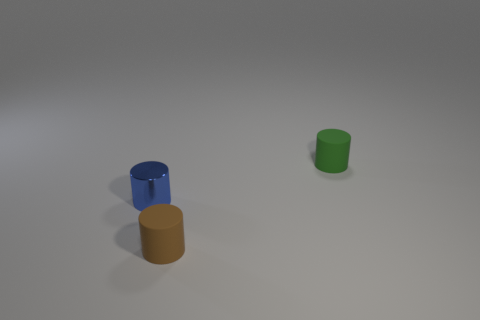Is there anything notable about the way the objects are positioned? Yes, the positioning of the objects could suggest a few interpretations. Artistically, it may represent compositional balance, with the green upright object creating a point of contrast against the two fallen objects. From a scientific perspective, it might represent an experiment about stability or center of gravity. It could also be a simple display of objects with no intended deeper significance.  Do these objects have any textures or patterns? From this vantage point, the objects appear to have uniform, smooth surfaces without any visible texture or patterning. The lack of intricate details suggests that they could be designed to emphasize form and color over surface decoration, allowing for clear visualization of their shapes and contours. 